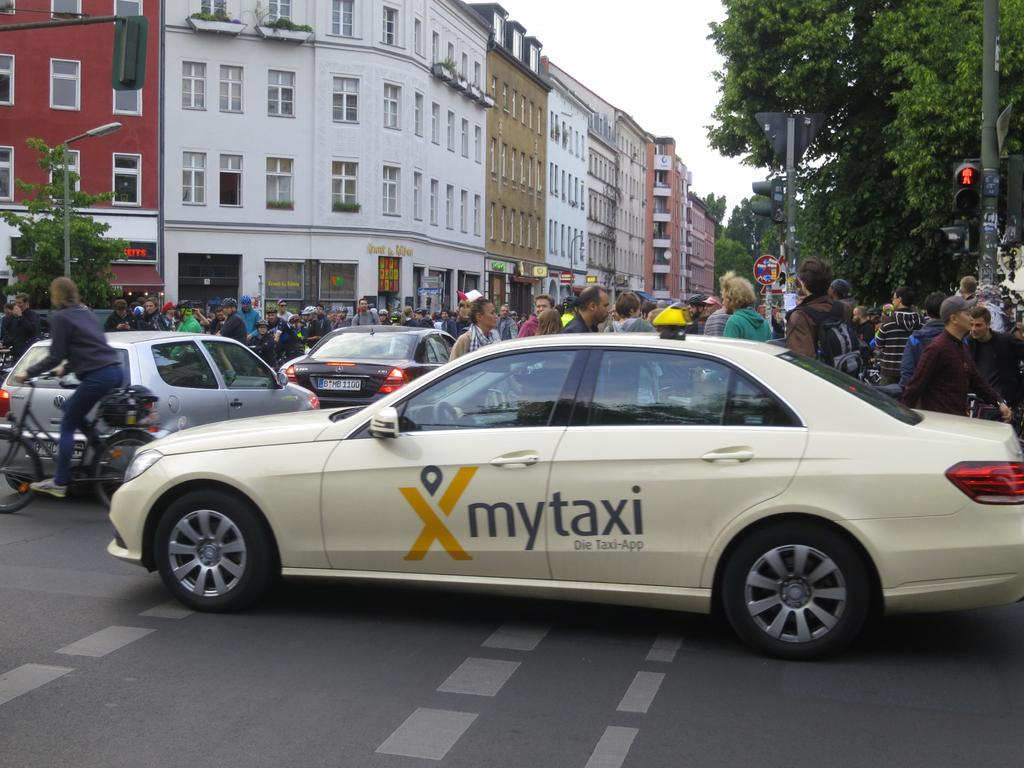<image>
Provide a brief description of the given image. A white car says my taxi on the doors. 